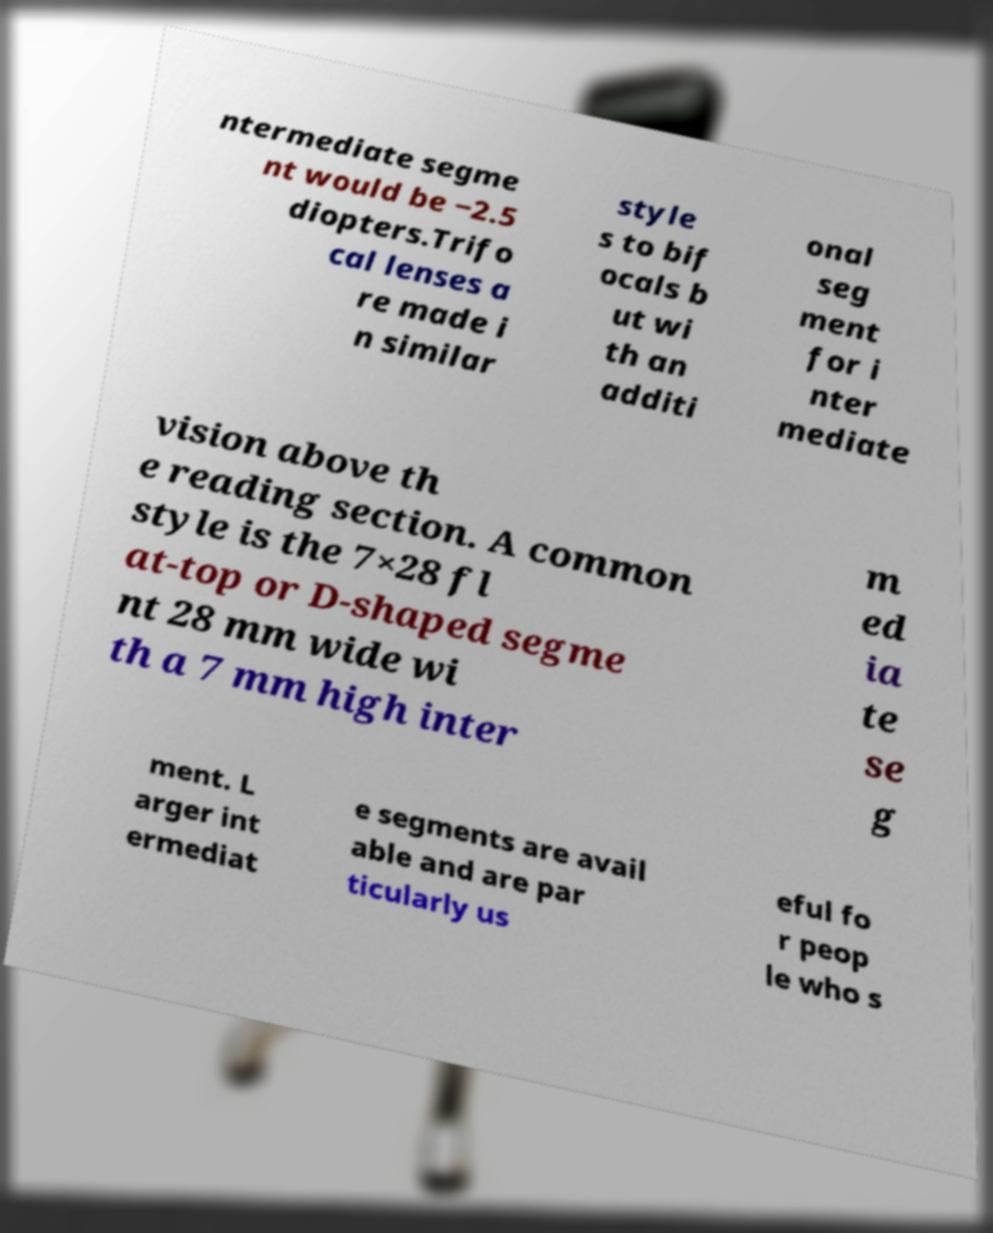Can you accurately transcribe the text from the provided image for me? ntermediate segme nt would be −2.5 diopters.Trifo cal lenses a re made i n similar style s to bif ocals b ut wi th an additi onal seg ment for i nter mediate vision above th e reading section. A common style is the 7×28 fl at-top or D-shaped segme nt 28 mm wide wi th a 7 mm high inter m ed ia te se g ment. L arger int ermediat e segments are avail able and are par ticularly us eful fo r peop le who s 